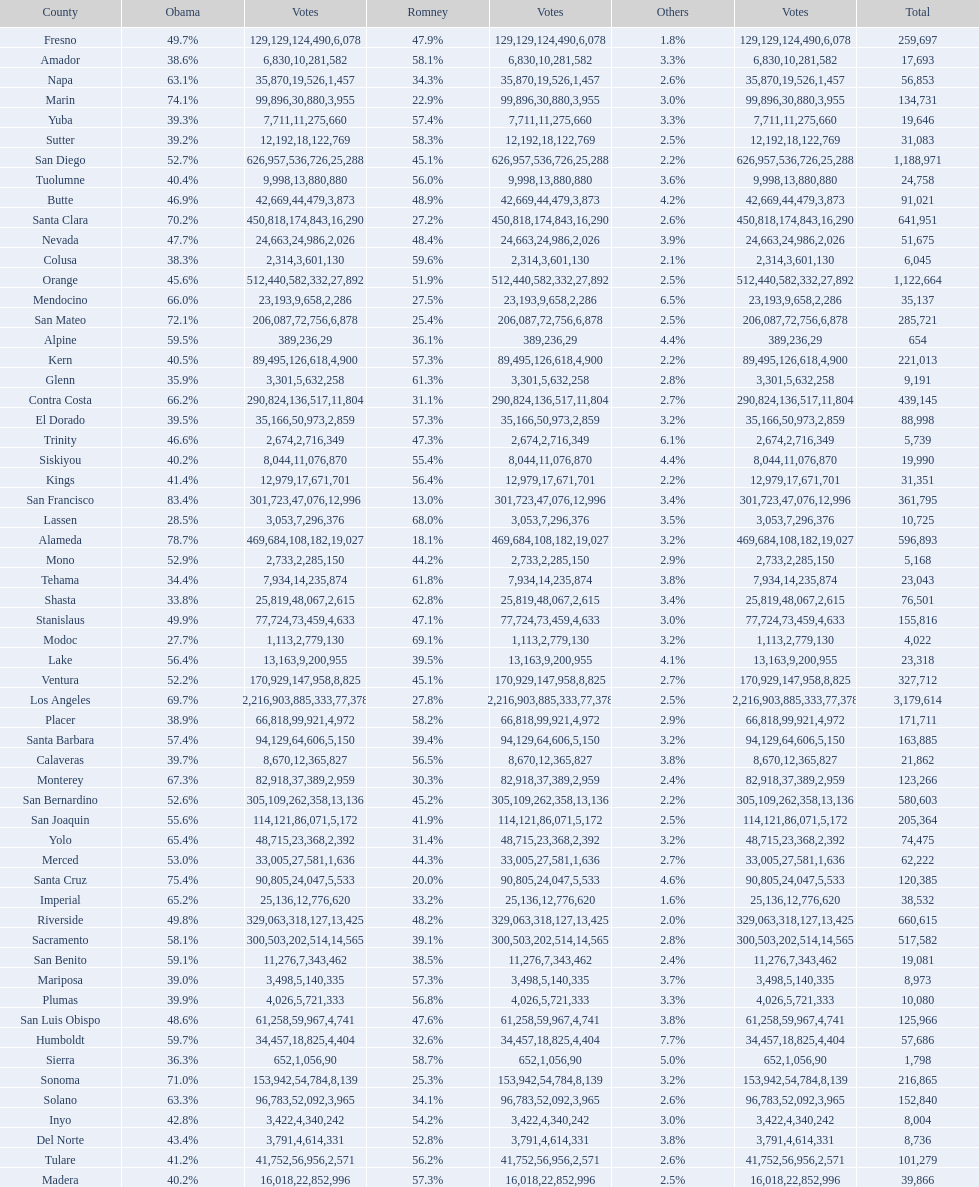Which county had the most total votes? Los Angeles. 